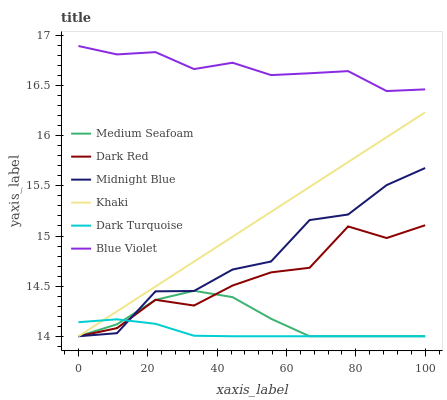Does Dark Turquoise have the minimum area under the curve?
Answer yes or no. Yes. Does Blue Violet have the maximum area under the curve?
Answer yes or no. Yes. Does Midnight Blue have the minimum area under the curve?
Answer yes or no. No. Does Midnight Blue have the maximum area under the curve?
Answer yes or no. No. Is Khaki the smoothest?
Answer yes or no. Yes. Is Midnight Blue the roughest?
Answer yes or no. Yes. Is Dark Red the smoothest?
Answer yes or no. No. Is Dark Red the roughest?
Answer yes or no. No. Does Blue Violet have the lowest value?
Answer yes or no. No. Does Blue Violet have the highest value?
Answer yes or no. Yes. Does Midnight Blue have the highest value?
Answer yes or no. No. Is Dark Turquoise less than Blue Violet?
Answer yes or no. Yes. Is Blue Violet greater than Midnight Blue?
Answer yes or no. Yes. Does Khaki intersect Medium Seafoam?
Answer yes or no. Yes. Is Khaki less than Medium Seafoam?
Answer yes or no. No. Is Khaki greater than Medium Seafoam?
Answer yes or no. No. Does Dark Turquoise intersect Blue Violet?
Answer yes or no. No. 